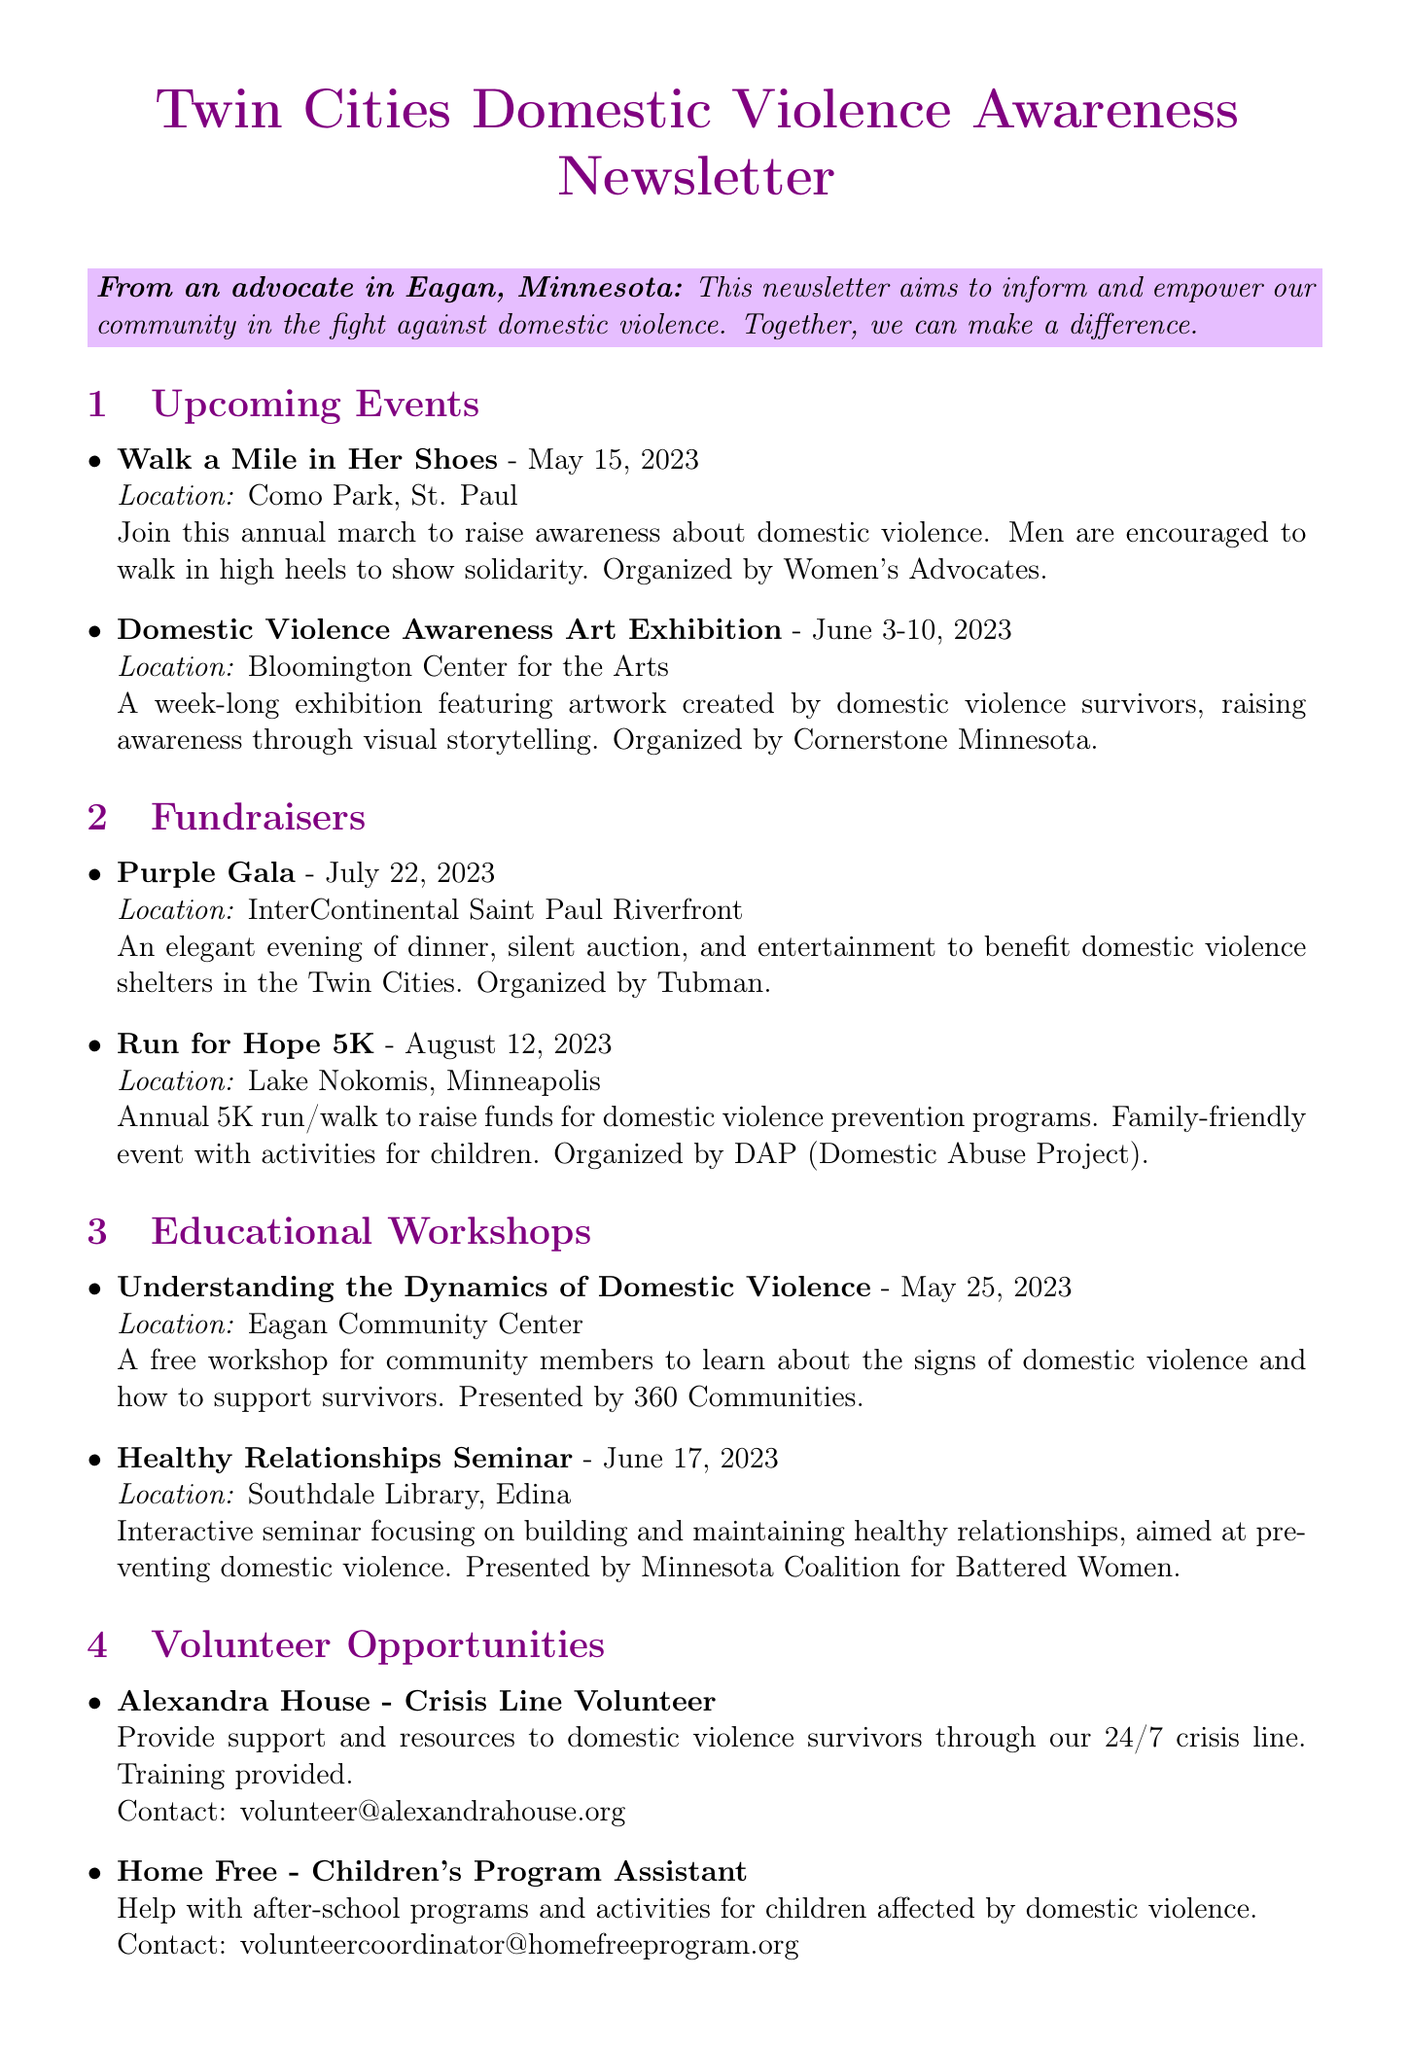What is the date of the "Walk a Mile in Her Shoes" event? The date is specifically mentioned in the document as May 15, 2023.
Answer: May 15, 2023 Who is the organizer of the "Purple Gala"? The document states that the event is organized by Tubman.
Answer: Tubman Where will the "Domestic Violence Awareness Art Exhibition" take place? The document provides the location as Bloomington Center for the Arts.
Answer: Bloomington Center for the Arts What type of event is the "Run for Hope 5K"? The document describes it as an annual 5K run/walk to raise funds for domestic violence prevention programs.
Answer: Annual 5K run/walk What is one service provided by Dakota County Domestic Violence Services? The document lists several services, and one example is the 24/7 crisis line.
Answer: 24/7 crisis line How many educational workshops are listed in the newsletter? The document lists two educational workshops under the relevant section.
Answer: Two Which organization is associated with the "Children's Program Assistant" volunteer role? The specific organization mentioned in the document is Home Free.
Answer: Home Free What is the location of the workshop on "Understanding the Dynamics of Domestic Violence"? The document specifies that it will be held at the Eagan Community Center.
Answer: Eagan Community Center When does the Domestic Violence Awareness Art Exhibition start? The start date of the exhibition from the document is June 3, 2023.
Answer: June 3, 2023 